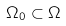<formula> <loc_0><loc_0><loc_500><loc_500>\Omega _ { 0 } \subset \Omega</formula> 